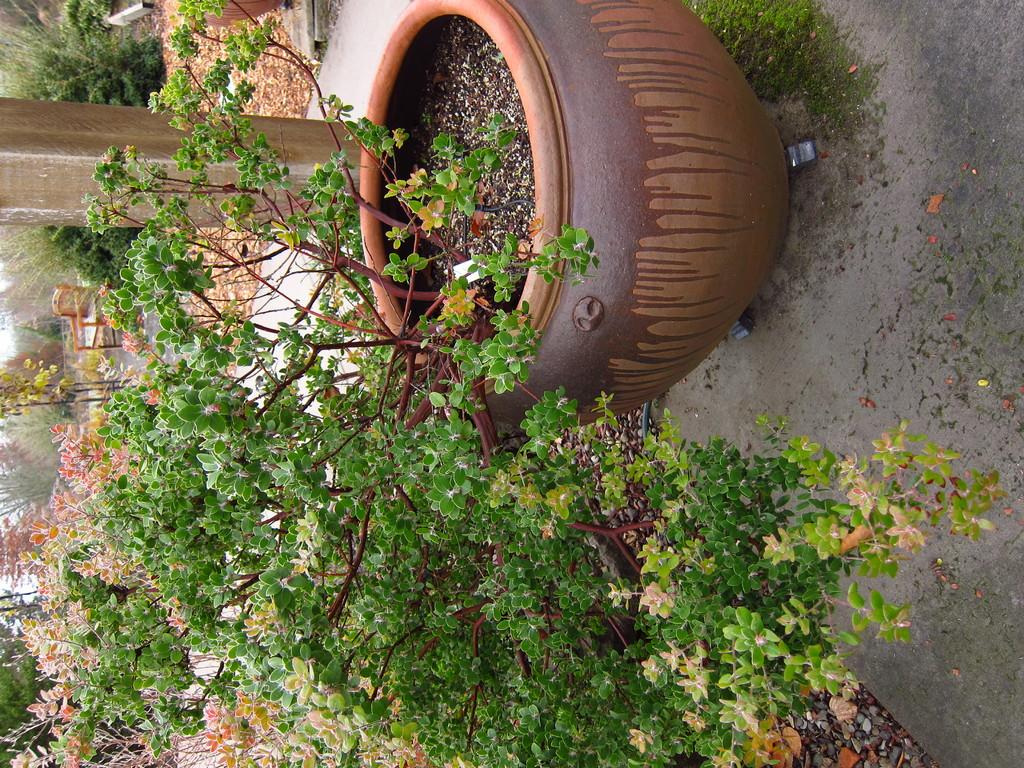What is in the pot that is visible in the image? There is a plant in a pot in the image. Where is the plant in the pot located? The plant in the pot is on the ground. What other types of vegetation can be seen in the image? There are other plants and trees visible in the image. What grade does the plant in the pot receive for its performance in the image? There is no grading system for plants in the image, so this question cannot be answered. 